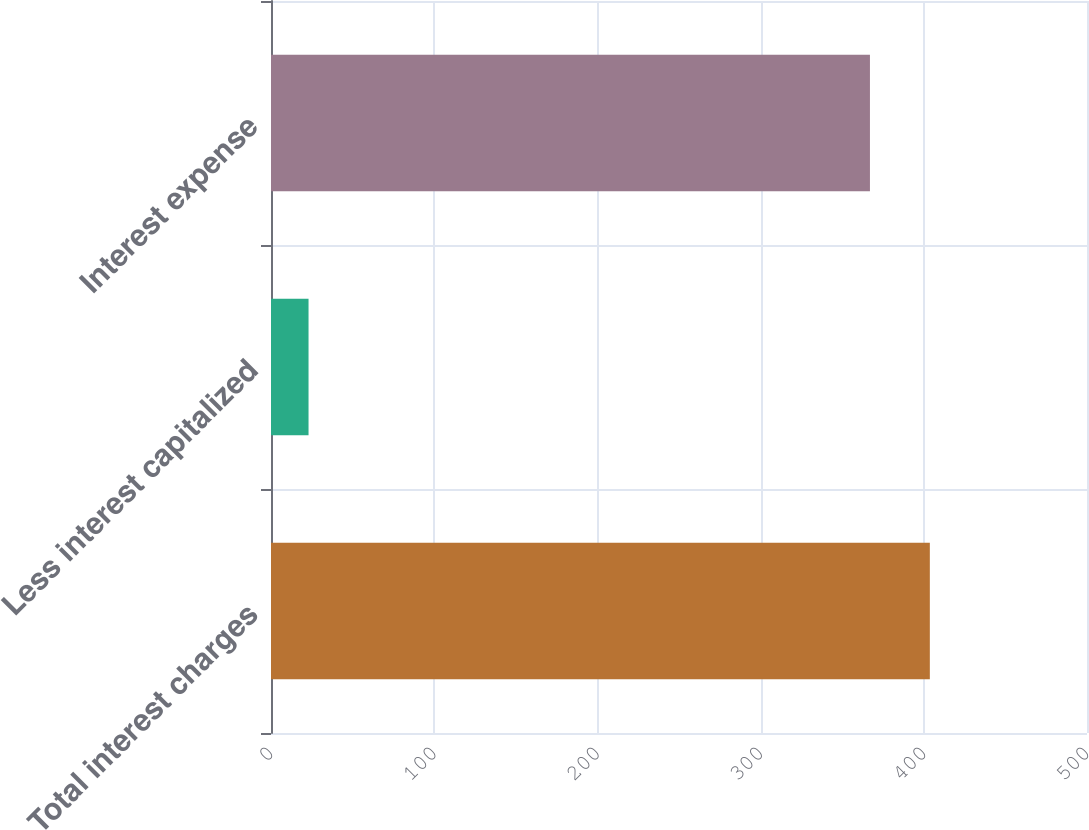Convert chart to OTSL. <chart><loc_0><loc_0><loc_500><loc_500><bar_chart><fcel>Total interest charges<fcel>Less interest capitalized<fcel>Interest expense<nl><fcel>403.7<fcel>23<fcel>367<nl></chart> 